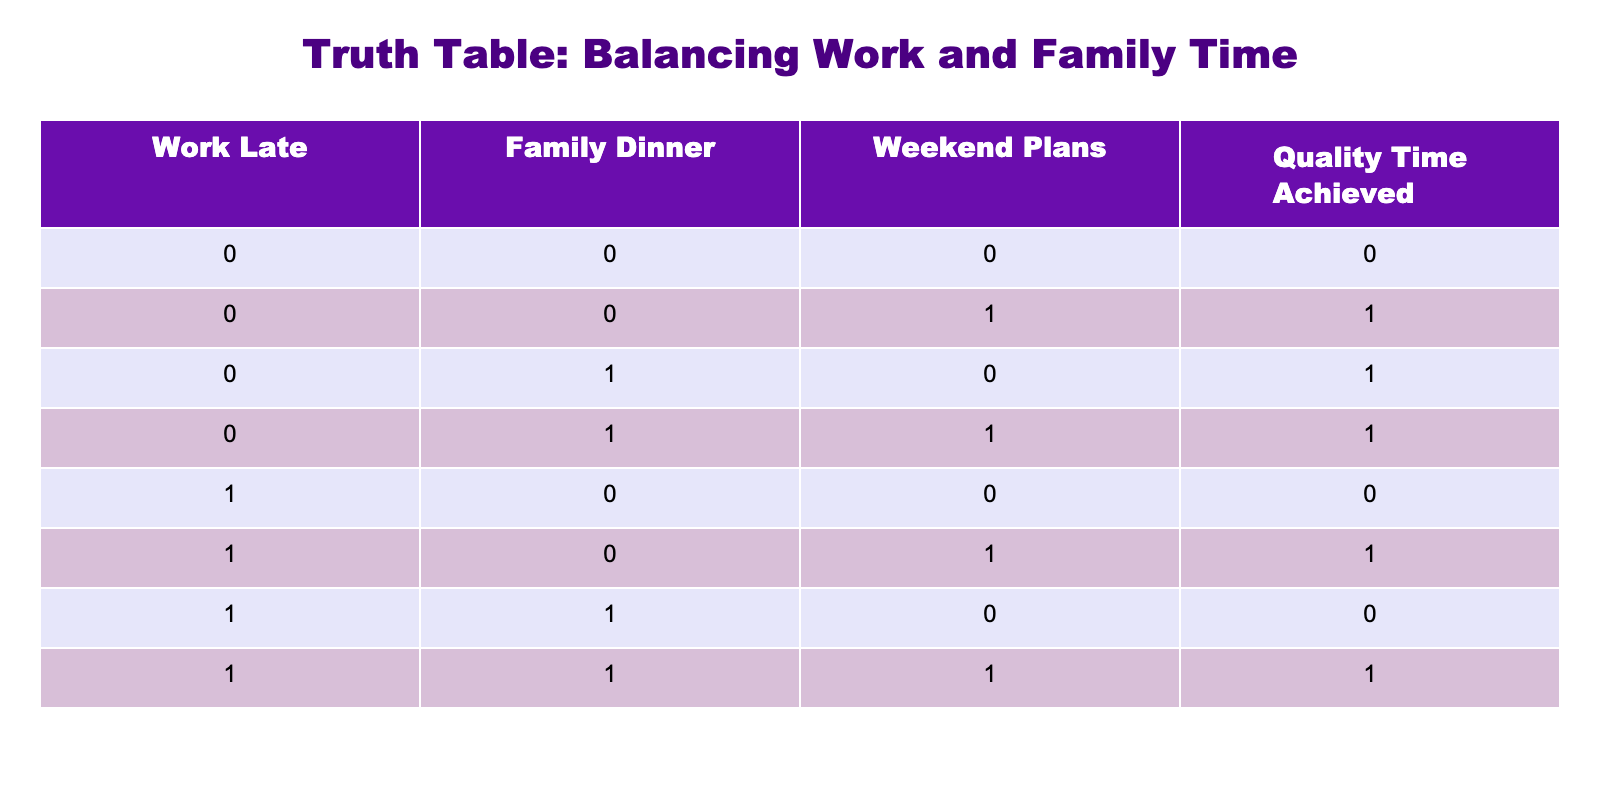What is the value of Quality Time Achieved when both Work Late and Family Dinner are equal to 0? Looking at the table, when both Work Late and Family Dinner are 0, the corresponding entry for Quality Time Achieved is 0 as seen in the first row.
Answer: 0 How many scenarios result in Quality Time Achieved being 1? To find this, we look at the rows where Quality Time Achieved is 1. These occur in the second, third, fourth, and sixth rows, totaling 4 scenarios.
Answer: 4 Is it true that if Work Late is 1, Quality Time Achieved can never be 1? By examining the rows with Work Late equal to 1 (fifth, sixth, seventh, and eighth rows), we observe that Quality Time Achieved is 1 only in the sixth and eighth rows, contradicting the statement.
Answer: No What is the total number of situations in which Family Dinner is 1? We examine the table and count how many times Family Dinner is 1, which occurs in the third, fourth, sixth, and eighth rows, leading to 4 instances.
Answer: 4 If a family is busy with weekend plans, what does this imply about Quality Time Achieved? Looking closely, we can see that even when Weekend Plans is 1 (rows two, four, six, and eight), Quality Time Achieved is 1 in rows two, four, and eight, which indicates that weekend plans can be compatible with achieving quality time.
Answer: Not necessarily implied What is the relation between Work Late and Quality Time Achieved in terms of presence and absence? From the table, we see that when Work Late is 0, Quality Time Achieved is 1 in three instances (rows two, three, and four), whereas when Work Late is 1, Quality Time Achieved can only be 1 in two instances (rows six and eight). This suggests a positive correlation when not working late.
Answer: Generally positive How many combinations lead to Quality Time Achieved of 0? By inspecting the table, the rows yielding a Quality Time Achieved value of 0 are the first and seventh rows, leading to a total of 2 combinations.
Answer: 2 What is the overall trend of Quality Time Achieved as Work Late increases? Analyzing the values, when Work Late transitions from 0 to 1, the chances of achieving Quality Time appear to decrease. Specifically, Quality Time Achieved is 1 for four situations when Work Late is 0, and for just two situations when Work Late is 1.
Answer: Decreasing trend 